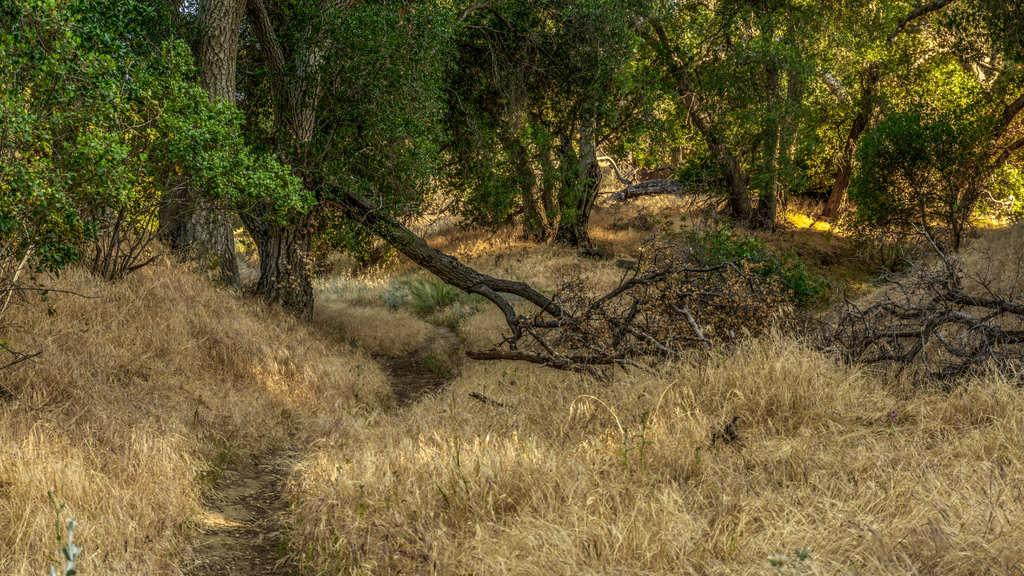What color is the grass covering the ground in the image? The ground in the image is covered with yellow grass. What type of vegetation can be seen on the grass ground? There are trees on the grass ground. What part of the trees is visible on the ground? There are tree trunks visible on the ground. What activity is taking place in the dirt surrounding the trees in the image? There is no dirt visible in the image, and no activity is taking place around the trees. 